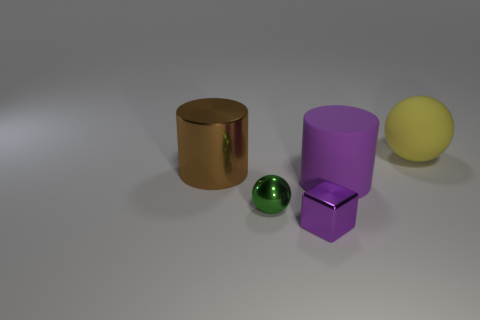What is the color of the thing that is both behind the small green metallic sphere and in front of the large brown object?
Your answer should be very brief. Purple. How many blocks are either yellow things or large purple rubber things?
Keep it short and to the point. 0. How many purple blocks have the same size as the yellow sphere?
Give a very brief answer. 0. What number of green balls are behind the purple object behind the shiny block?
Offer a terse response. 0. There is a object that is on the right side of the small purple metallic block and on the left side of the yellow ball; how big is it?
Give a very brief answer. Large. Is the number of green cylinders greater than the number of green metal objects?
Keep it short and to the point. No. Are there any rubber cylinders of the same color as the metallic cube?
Provide a succinct answer. Yes. Do the matte thing behind the shiny cylinder and the small block have the same size?
Give a very brief answer. No. Are there fewer large rubber cylinders than shiny objects?
Provide a succinct answer. Yes. Is there another big brown cylinder made of the same material as the big brown cylinder?
Offer a very short reply. No. 